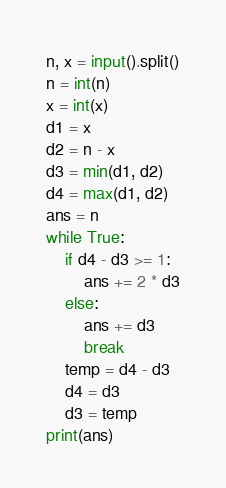Convert code to text. <code><loc_0><loc_0><loc_500><loc_500><_Python_>n, x = input().split()
n = int(n)
x = int(x)
d1 = x
d2 = n - x
d3 = min(d1, d2)
d4 = max(d1, d2)
ans = n
while True:
    if d4 - d3 >= 1:
        ans += 2 * d3
    else:
        ans += d3
        break
    temp = d4 - d3
    d4 = d3
    d3 = temp
print(ans)</code> 